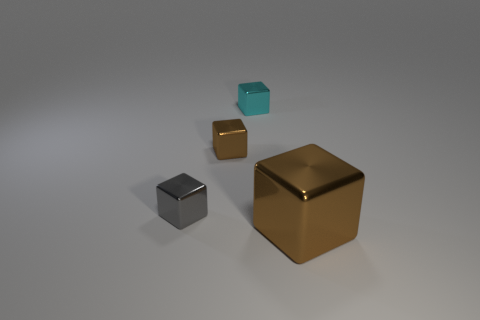Add 1 small gray cylinders. How many objects exist? 5 Subtract 0 red cylinders. How many objects are left? 4 Subtract all big cyan blocks. Subtract all small cyan metallic cubes. How many objects are left? 3 Add 3 gray objects. How many gray objects are left? 4 Add 2 tiny gray blocks. How many tiny gray blocks exist? 3 